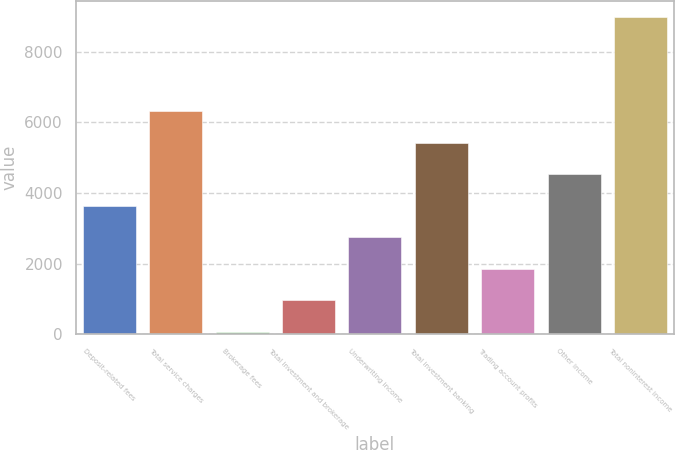Convert chart. <chart><loc_0><loc_0><loc_500><loc_500><bar_chart><fcel>Deposit-related fees<fcel>Total service charges<fcel>Brokerage fees<fcel>Total investment and brokerage<fcel>Underwriting income<fcel>Total investment banking<fcel>Trading account profits<fcel>Other income<fcel>Total noninterest income<nl><fcel>3634<fcel>6304<fcel>74<fcel>964<fcel>2744<fcel>5414<fcel>1854<fcel>4524<fcel>8974<nl></chart> 